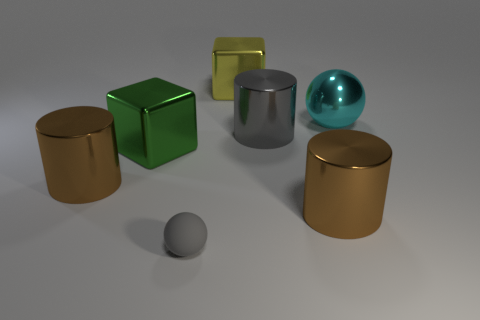Add 2 red balls. How many objects exist? 9 Subtract all balls. How many objects are left? 5 Subtract 1 brown cylinders. How many objects are left? 6 Subtract all green cylinders. Subtract all large green metal things. How many objects are left? 6 Add 5 gray rubber balls. How many gray rubber balls are left? 6 Add 1 green metal things. How many green metal things exist? 2 